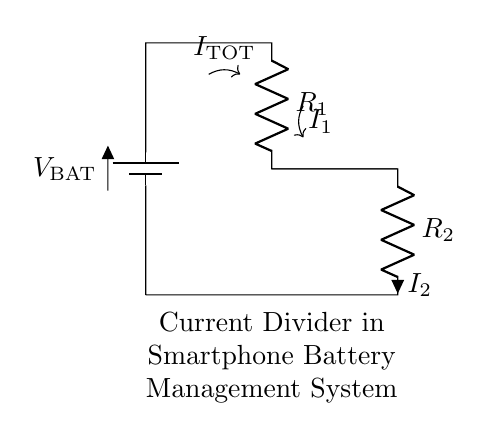What is the total current entering the circuit? The total current entering the circuit is labeled as I_TOTAL, which is the current supplied by the battery.
Answer: I_TOTAL What are the resistance values in this circuit? The circuit has two resistors, R_1 and R_2. The specific values are not provided in the diagram, but they are part of the current divider network.
Answer: R_1 and R_2 Which resistor will have the highest current flow? In a current divider, the resistor with the lower resistance value will have a higher current flow. Therefore, if one resistor has a lower resistance than the other, it would receive more current, which is defined as I_2 in this diagram.
Answer: R_2 (if R_2 < R_1) What does the current divider rule state? The current divider rule states that the current flowing through a particular branch of a parallel circuit is inversely proportional to the resistance of that branch. This means that lower resistance will carry more current.
Answer: Inversely proportional to resistance If R_1 = 4 ohms and R_2 = 2 ohms, what is the ratio of the currents I_1 to I_2? Using the current divider rule, I_1/I_2 = R_2/R_1. Plugging in the numbers gives I_1/I_2 = 2/4 = 1/2. This means for every 1 unit of current in I_2, there are 0.5 units in I_1.
Answer: 1:2 What is the purpose of a current divider in battery management systems? The purpose of a current divider in battery management systems is to distribute the total current from the battery into multiple paths based on the resistor values, which ensures efficient charging and discharging of the battery cells.
Answer: Efficient current distribution 